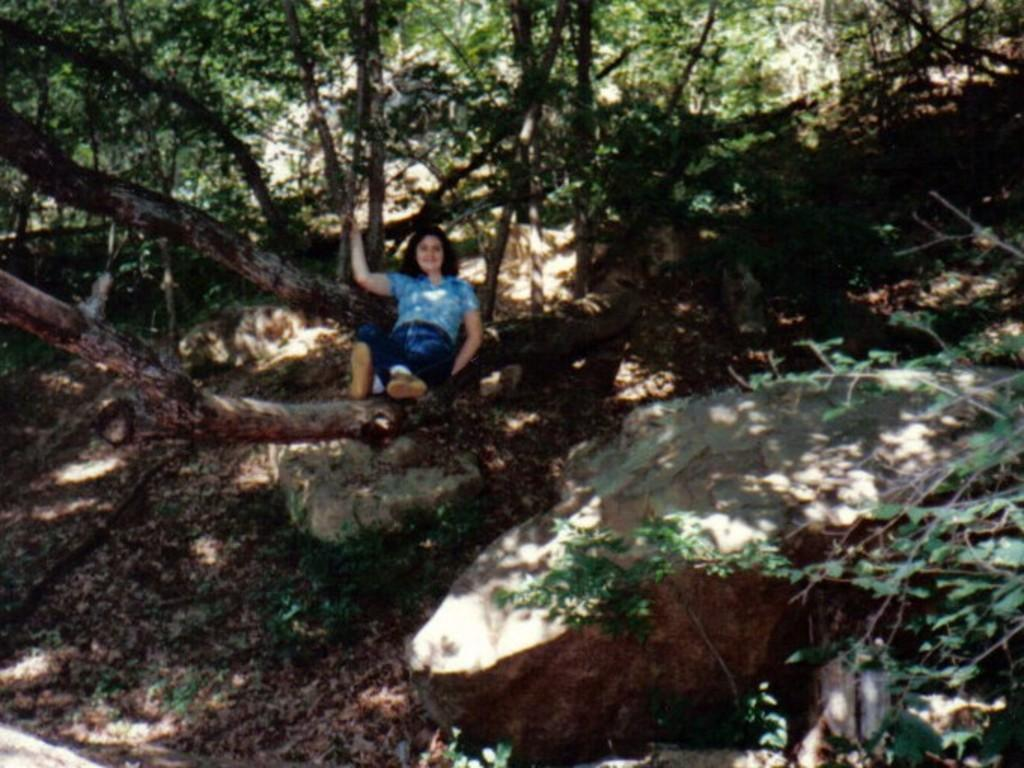Who is in the image? There is a woman in the image. What is the woman doing in the image? The woman is sitting on the branch of a tree. What expression does the woman have? The woman has a smile on her face. What can be seen on the ground in the image? There are rocks visible in the image. What is visible in the background of the image? There are trees in the background of the image. What word is being printed on the rocks in the image? There is no word being printed on the rocks in the image; they are just rocks. How many apples are visible on the tree branch where the woman is sitting? There are no apples visible on the tree branch where the woman is sitting; only the woman is present. 